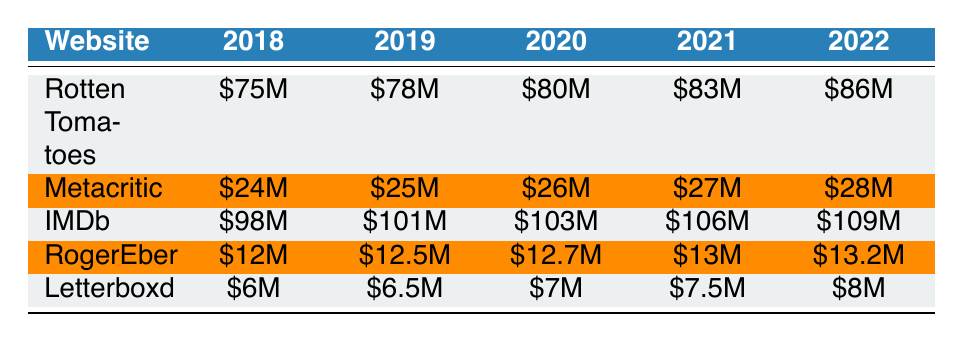What was the revenue of Rotten Tomatoes in 2020? The table shows the revenue for Rotten Tomatoes in 2020, which is listed directly and equals 80 million dollars.
Answer: 80 million Which website saw the highest yearly subscription revenue in 2021? By examining the revenue figures for each website in 2021, IMDb has the highest revenue at 106 million dollars.
Answer: IMDb What is the sum of the revenues of Metacritic over the years 2018 to 2022? The revenues for Metacritic in those years are 24 million, 25 million, 26 million, 27 million, and 28 million. Adding these gives: 24 + 25 + 26 + 27 + 28 = 130 million.
Answer: 130 million Did Letterboxd have a higher revenue than RogerEbert.com in 2019? In 2019, Letterboxd's revenue was 6.5 million dollars, while RogerEbert.com's revenue was 12.5 million dollars. Since 6.5 million is less than 12.5 million, the statement is false.
Answer: No What was the average revenue of all websites in 2022? The revenue figures for 2022 are: 86 million (Rotten Tomatoes), 28 million (Metacritic), 109 million (IMDb), 13.2 million (RogerEbert.com), and 8 million (Letterboxd). Summing these gives 86 + 28 + 109 + 13.2 + 8 = 244. Dividing by the number of websites (5) gives an average of 48.8 million.
Answer: 48.8 million 